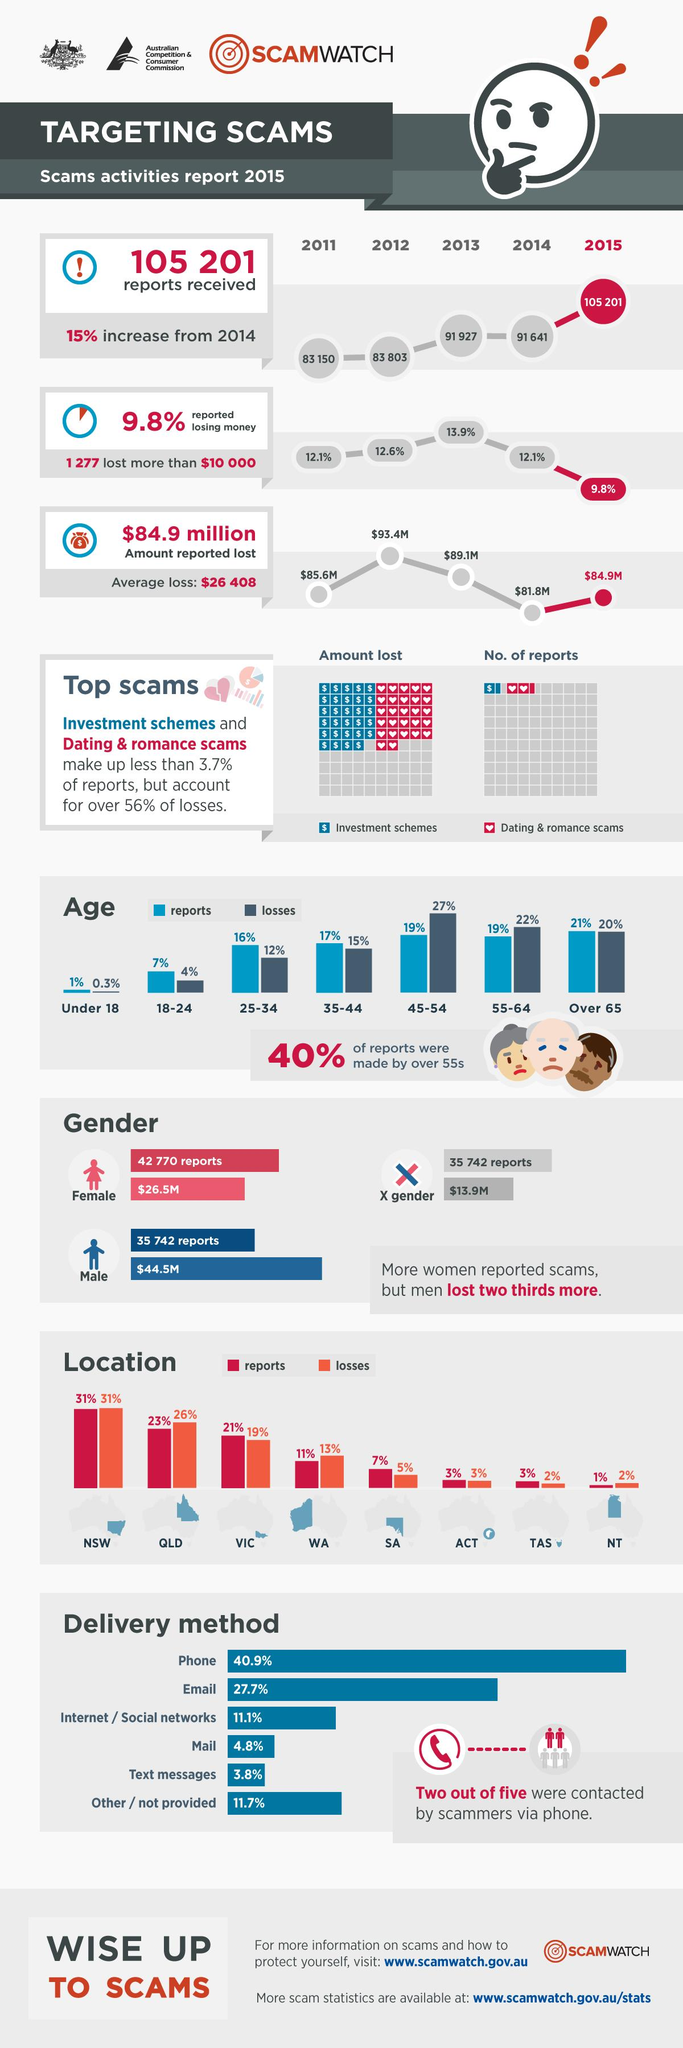Specify some key components in this picture. The age group of 45-54 had the highest reported losses due to scams, according to reported data. The reported loss in 2012 was the highest among all the years reported. During the period 2011-2015, the lowest percentage of money lost was 9.8%. The dating and romance scam had a larger number of reported cases than any other type of scam. According to the survey, the age group that reported the highest percentage of scams is individuals over the age of 65. 